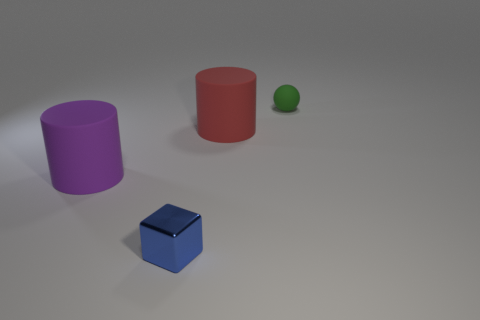What colors are the objects in this image? The objects in the image include a purple cylinder, a red cylinder, a green sphere, and a blue cube. Are there any patterns or textures on these objects? All objects have a matte finish with no distinct patterns or textures, lending to their simple yet striking visual appeal. 